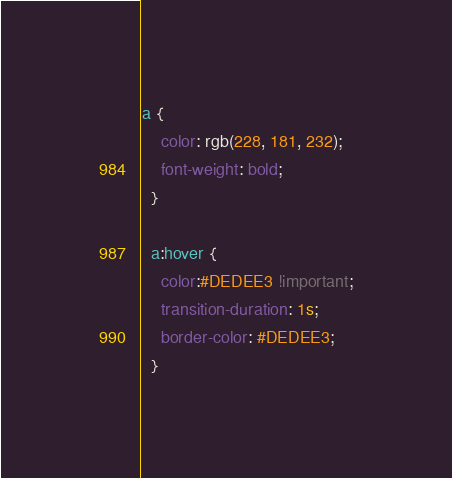Convert code to text. <code><loc_0><loc_0><loc_500><loc_500><_CSS_>a {
    color: rgb(228, 181, 232);
    font-weight: bold;
  }
  
  a:hover {
    color:#DEDEE3 !important;
    transition-duration: 1s;
    border-color: #DEDEE3;
  }
</code> 